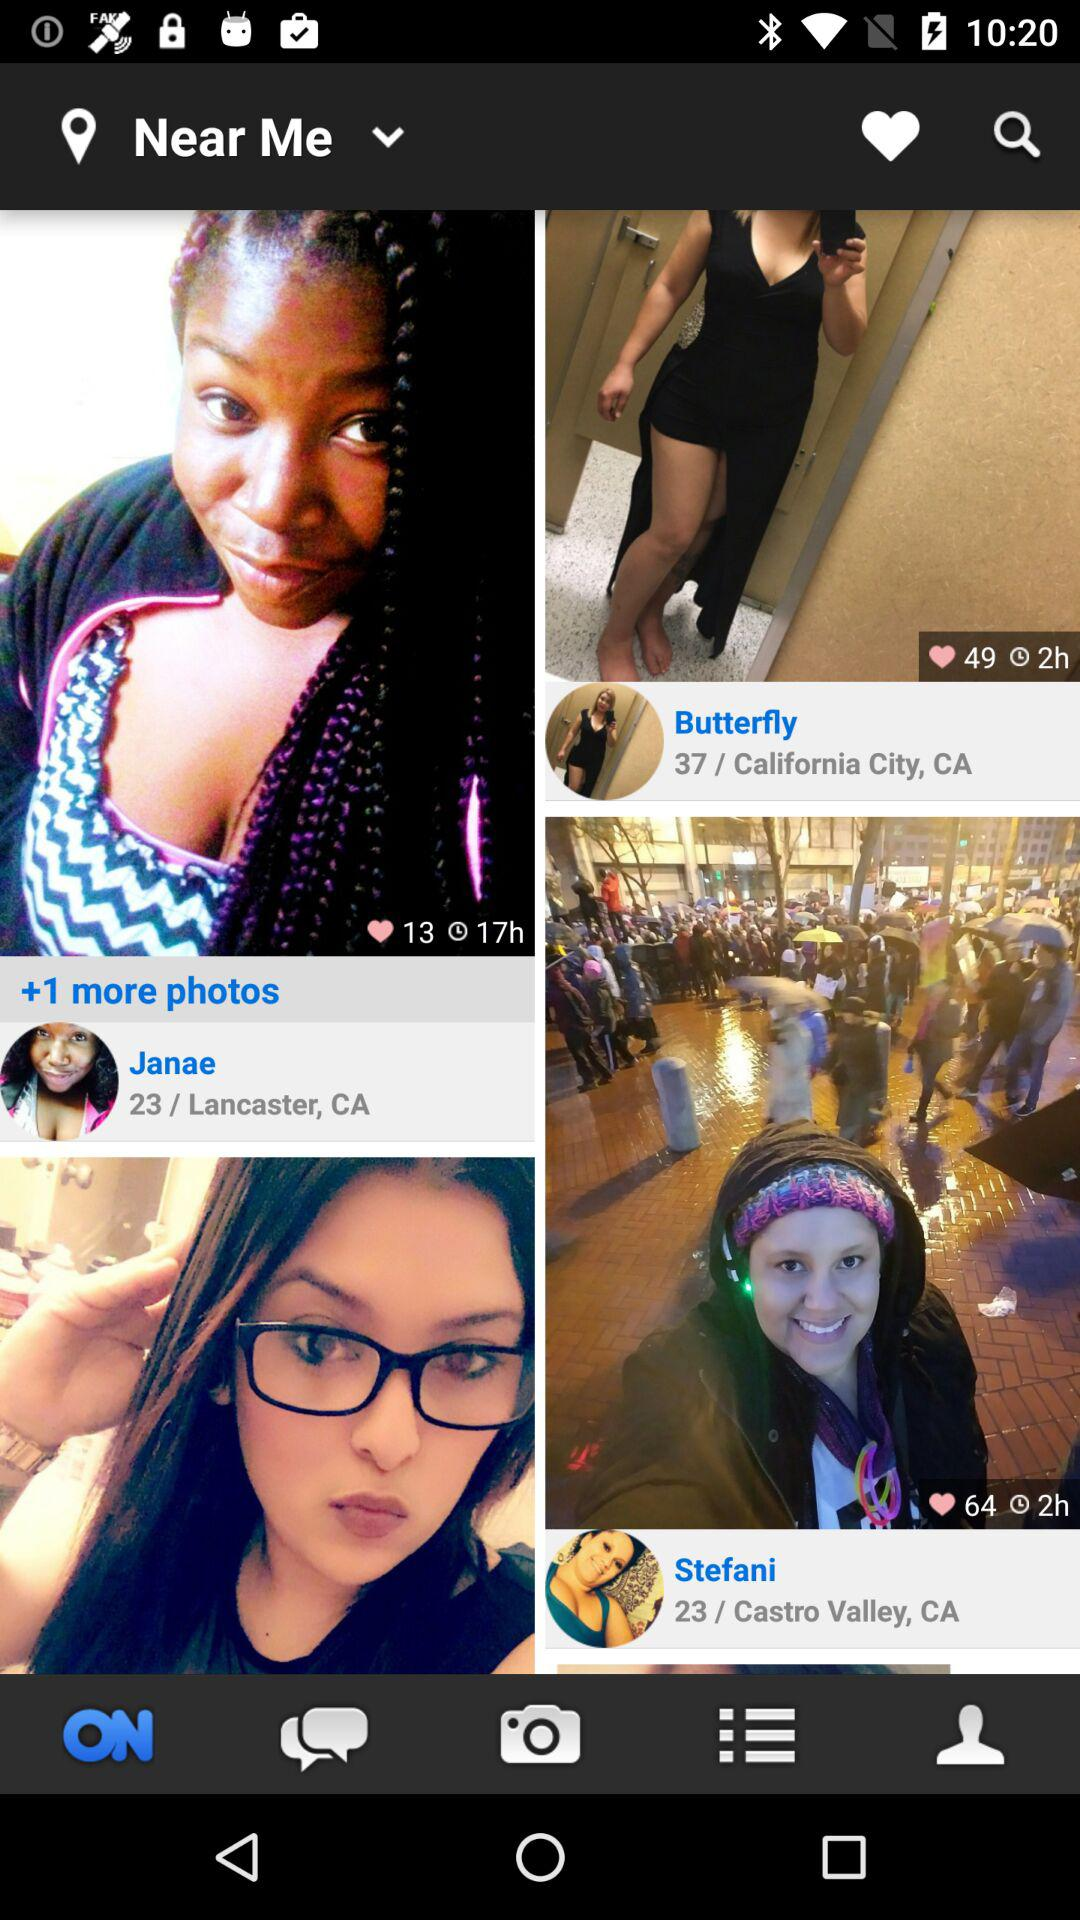When did Janae post the picture? Janae posted the picture 17 hours ago. 